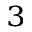Convert formula to latex. <formula><loc_0><loc_0><loc_500><loc_500>^ { 3 }</formula> 